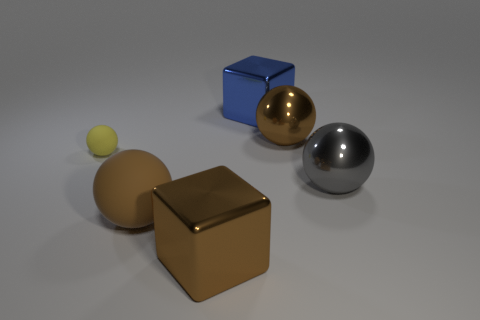Subtract 1 spheres. How many spheres are left? 3 Add 2 brown metal things. How many objects exist? 8 Subtract all blocks. How many objects are left? 4 Add 3 big rubber blocks. How many big rubber blocks exist? 3 Subtract 1 blue cubes. How many objects are left? 5 Subtract all big gray things. Subtract all large blue metal objects. How many objects are left? 4 Add 4 large spheres. How many large spheres are left? 7 